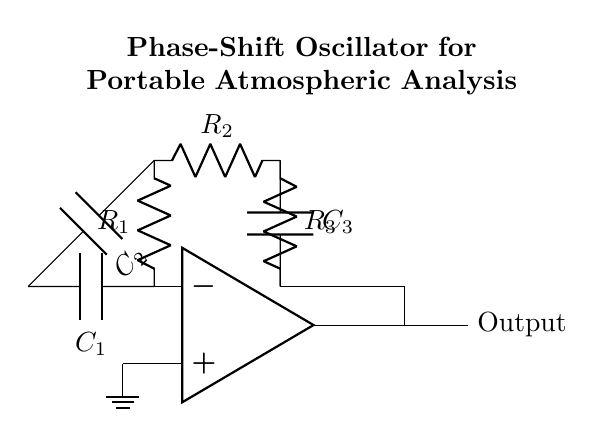What are the components used in this oscillator circuit? The circuit includes an operational amplifier, three resistors labeled R1, R2, R3, and three capacitors labeled C1, C2, C3.
Answer: Operational amplifier, R1, R2, R3, C1, C2, C3 What is the purpose of the operational amplifier in this circuit? The operational amplifier amplifies the input signal and helps sustain oscillation through feedback.
Answer: Amplification and feedback How many capacitors are used in this phase-shift oscillator? The circuit contains three capacitors, as indicated by the labels C1, C2, and C3.
Answer: Three What is the expected output of this oscillator circuit? The output is a periodic signal generated through the oscillation process of the circuit.
Answer: Periodic signal Why is the phase shift important in this oscillator circuit? The phase shift is crucial as it ensures that the feedback is positive and meets the condition for sustained oscillations, typically requiring a total phase shift of 360 degrees.
Answer: Sustained oscillation condition What is the role of resistors in this phase-shift oscillator? The resistors determine the timing characteristics and the frequency of oscillation by influencing the charging and discharging rates of the capacitors.
Answer: Timing characteristics and frequency setting Which terminals of the operational amplifier are connected to ground? The non-inverting terminal of the operational amplifier is connected to ground.
Answer: Non-inverting terminal 